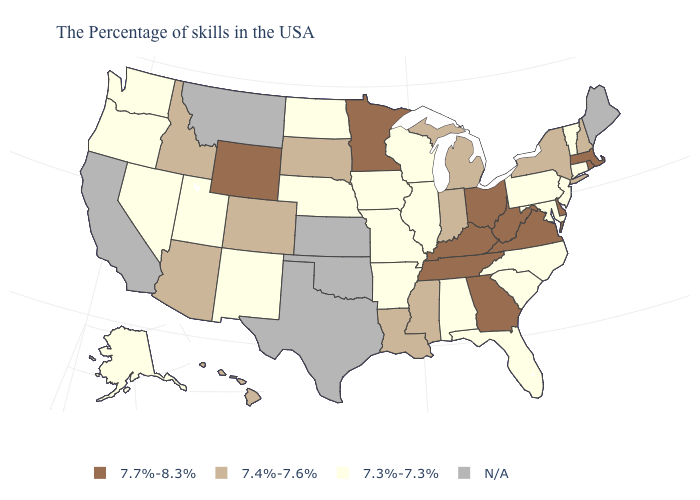Does Massachusetts have the highest value in the USA?
Write a very short answer. Yes. What is the value of New Mexico?
Answer briefly. 7.3%-7.3%. Which states have the highest value in the USA?
Write a very short answer. Massachusetts, Rhode Island, Delaware, Virginia, West Virginia, Ohio, Georgia, Kentucky, Tennessee, Minnesota, Wyoming. What is the value of Texas?
Quick response, please. N/A. Which states hav the highest value in the MidWest?
Be succinct. Ohio, Minnesota. Name the states that have a value in the range 7.3%-7.3%?
Give a very brief answer. Vermont, Connecticut, New Jersey, Maryland, Pennsylvania, North Carolina, South Carolina, Florida, Alabama, Wisconsin, Illinois, Missouri, Arkansas, Iowa, Nebraska, North Dakota, New Mexico, Utah, Nevada, Washington, Oregon, Alaska. Which states have the lowest value in the USA?
Concise answer only. Vermont, Connecticut, New Jersey, Maryland, Pennsylvania, North Carolina, South Carolina, Florida, Alabama, Wisconsin, Illinois, Missouri, Arkansas, Iowa, Nebraska, North Dakota, New Mexico, Utah, Nevada, Washington, Oregon, Alaska. Name the states that have a value in the range N/A?
Concise answer only. Maine, Kansas, Oklahoma, Texas, Montana, California. What is the value of Ohio?
Short answer required. 7.7%-8.3%. Does the first symbol in the legend represent the smallest category?
Write a very short answer. No. What is the highest value in states that border Delaware?
Give a very brief answer. 7.3%-7.3%. Which states have the lowest value in the USA?
Answer briefly. Vermont, Connecticut, New Jersey, Maryland, Pennsylvania, North Carolina, South Carolina, Florida, Alabama, Wisconsin, Illinois, Missouri, Arkansas, Iowa, Nebraska, North Dakota, New Mexico, Utah, Nevada, Washington, Oregon, Alaska. Name the states that have a value in the range 7.7%-8.3%?
Write a very short answer. Massachusetts, Rhode Island, Delaware, Virginia, West Virginia, Ohio, Georgia, Kentucky, Tennessee, Minnesota, Wyoming. 